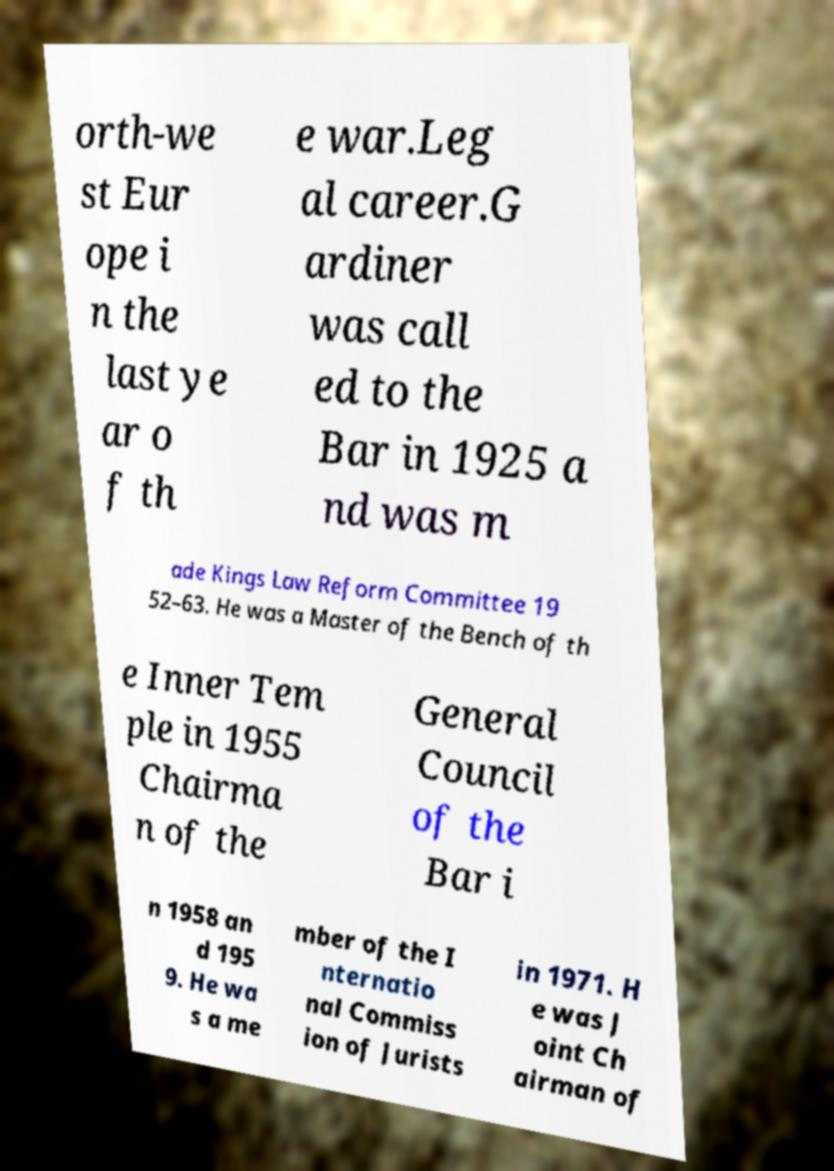Could you extract and type out the text from this image? orth-we st Eur ope i n the last ye ar o f th e war.Leg al career.G ardiner was call ed to the Bar in 1925 a nd was m ade Kings Law Reform Committee 19 52–63. He was a Master of the Bench of th e Inner Tem ple in 1955 Chairma n of the General Council of the Bar i n 1958 an d 195 9. He wa s a me mber of the I nternatio nal Commiss ion of Jurists in 1971. H e was J oint Ch airman of 